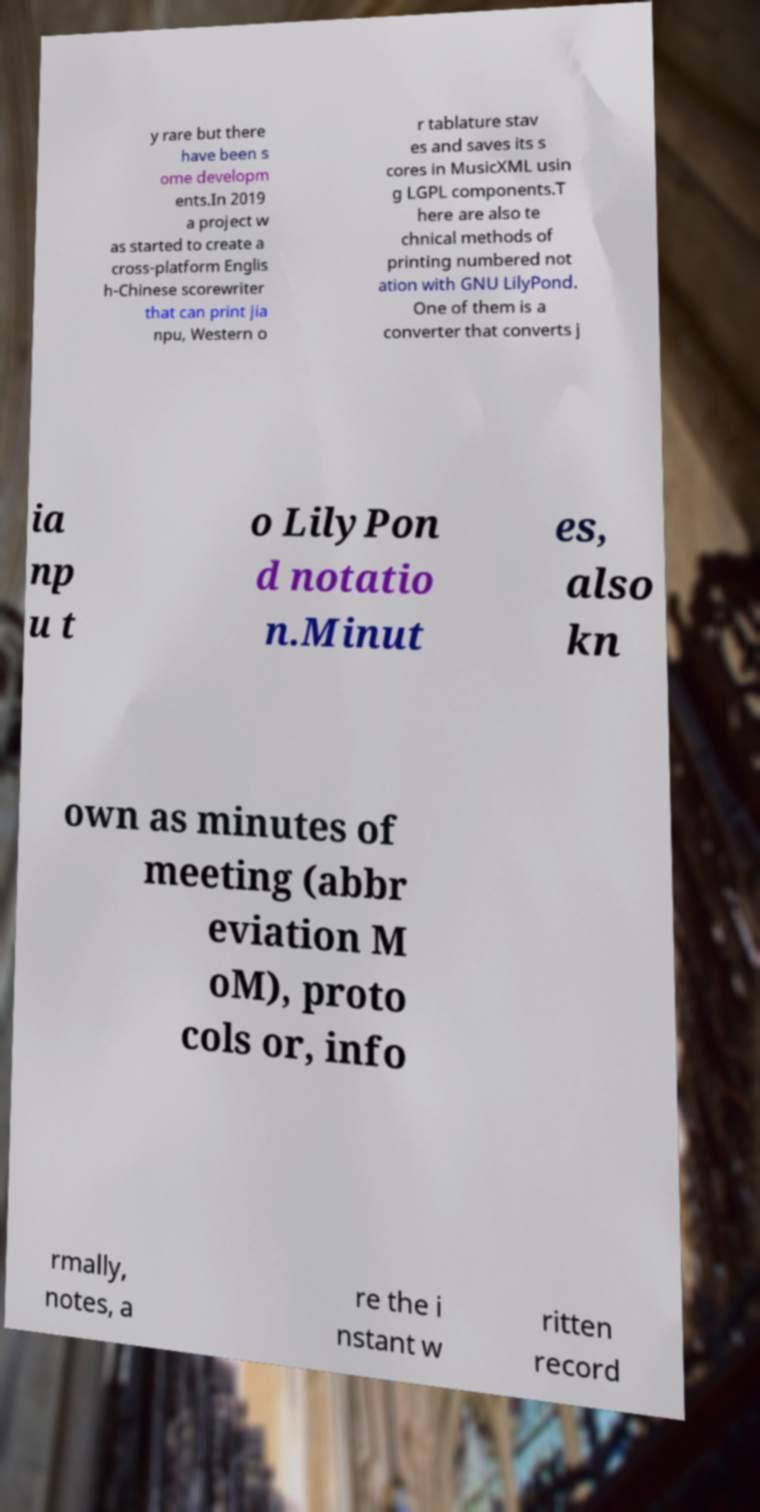Can you read and provide the text displayed in the image?This photo seems to have some interesting text. Can you extract and type it out for me? y rare but there have been s ome developm ents.In 2019 a project w as started to create a cross-platform Englis h-Chinese scorewriter that can print jia npu, Western o r tablature stav es and saves its s cores in MusicXML usin g LGPL components.T here are also te chnical methods of printing numbered not ation with GNU LilyPond. One of them is a converter that converts j ia np u t o LilyPon d notatio n.Minut es, also kn own as minutes of meeting (abbr eviation M oM), proto cols or, info rmally, notes, a re the i nstant w ritten record 